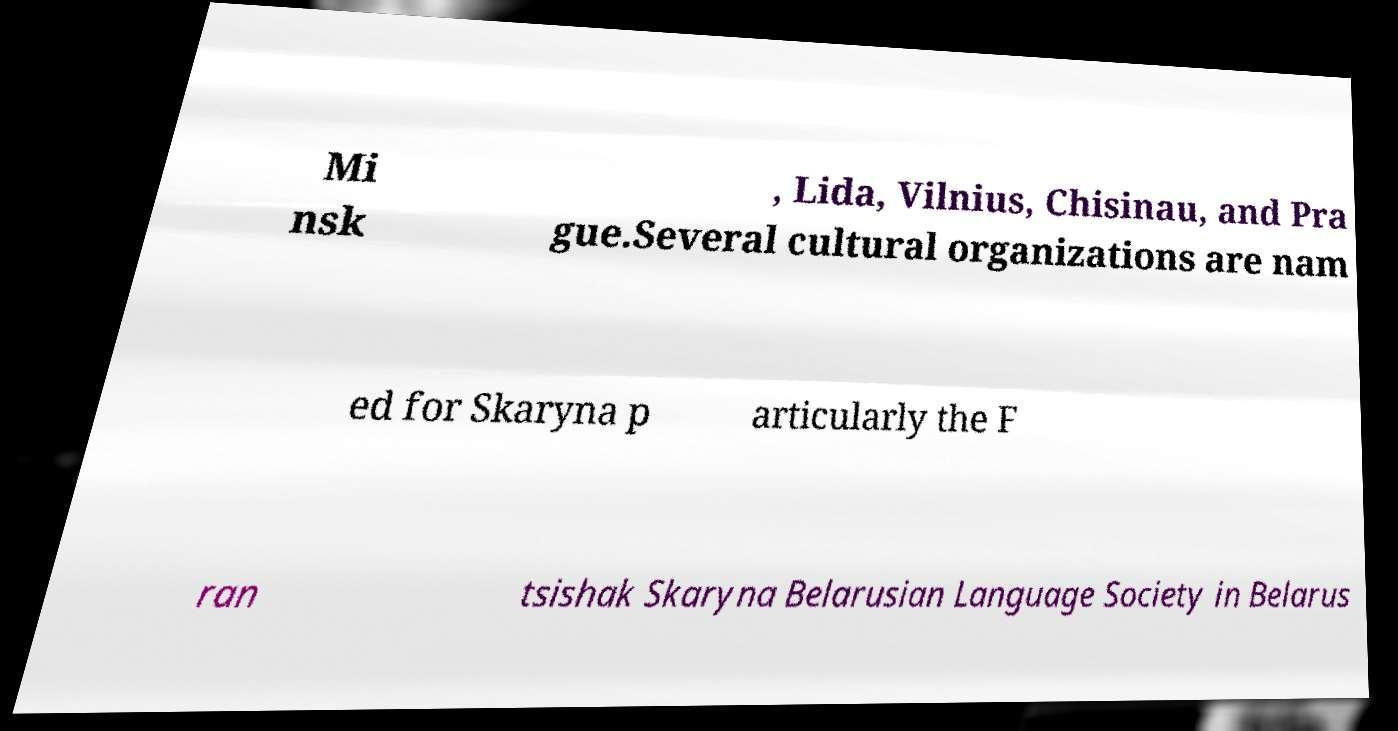Could you extract and type out the text from this image? Mi nsk , Lida, Vilnius, Chisinau, and Pra gue.Several cultural organizations are nam ed for Skaryna p articularly the F ran tsishak Skaryna Belarusian Language Society in Belarus 